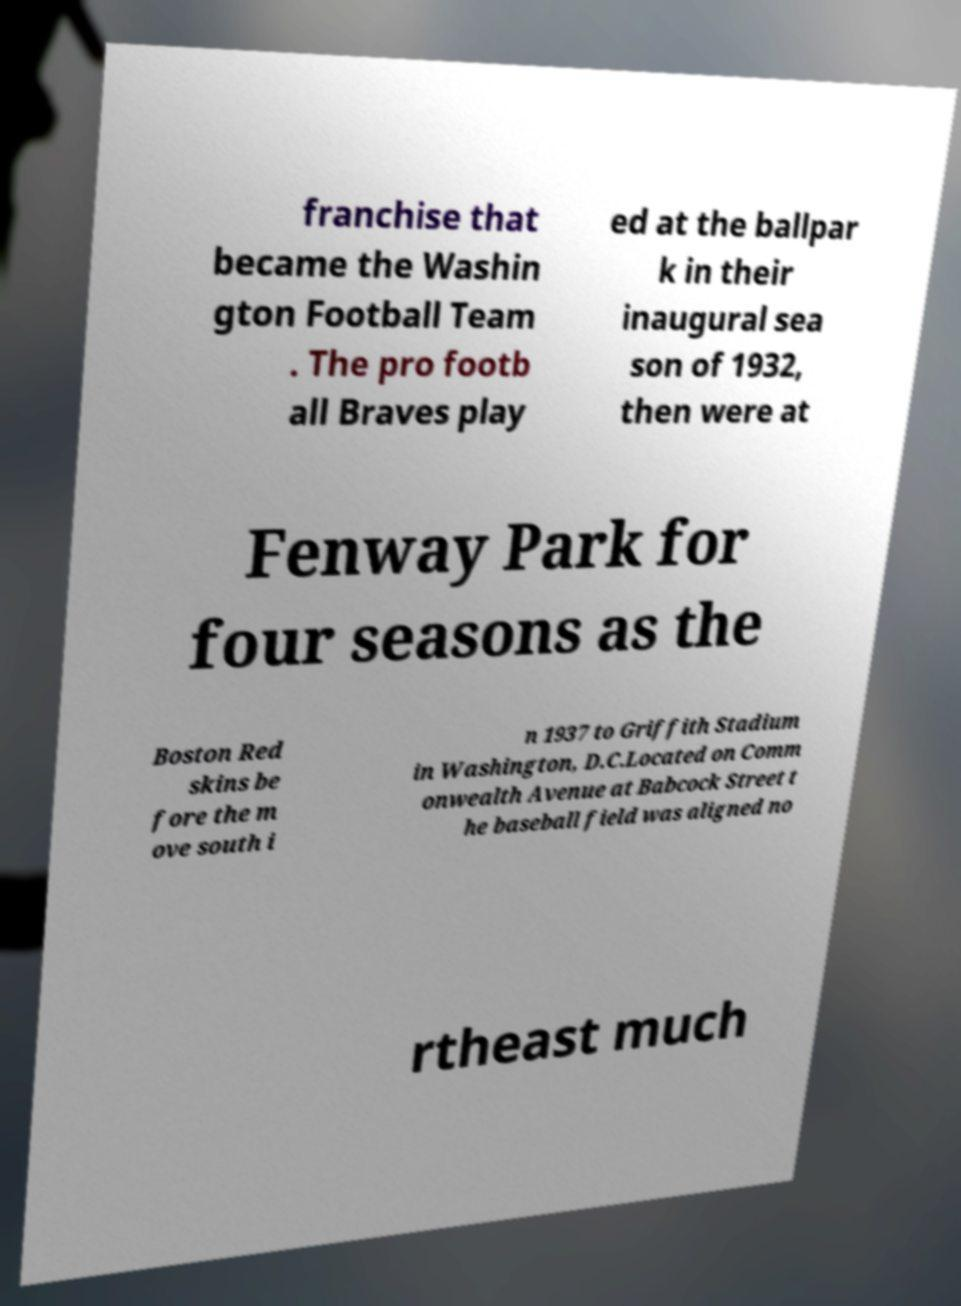I need the written content from this picture converted into text. Can you do that? franchise that became the Washin gton Football Team . The pro footb all Braves play ed at the ballpar k in their inaugural sea son of 1932, then were at Fenway Park for four seasons as the Boston Red skins be fore the m ove south i n 1937 to Griffith Stadium in Washington, D.C.Located on Comm onwealth Avenue at Babcock Street t he baseball field was aligned no rtheast much 